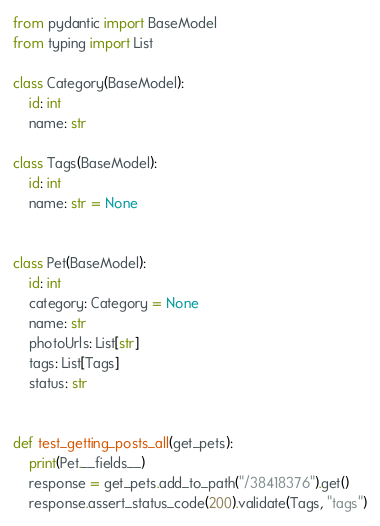Convert code to text. <code><loc_0><loc_0><loc_500><loc_500><_Python_>from pydantic import BaseModel
from typing import List

class Category(BaseModel):
    id: int
    name: str

class Tags(BaseModel):
    id: int
    name: str = None


class Pet(BaseModel):
    id: int
    category: Category = None
    name: str
    photoUrls: List[str]
    tags: List[Tags]
    status: str


def test_getting_posts_all(get_pets):
    print(Pet.__fields__)
    response = get_pets.add_to_path("/38418376").get()
    response.assert_status_code(200).validate(Tags, "tags")


</code> 